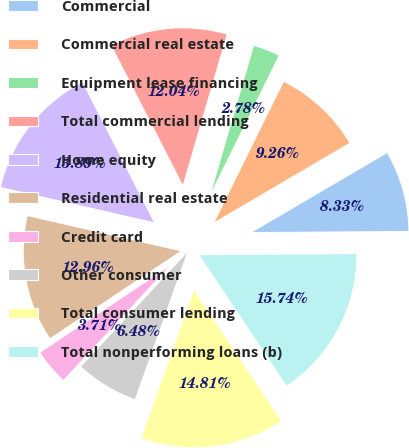Convert chart to OTSL. <chart><loc_0><loc_0><loc_500><loc_500><pie_chart><fcel>Commercial<fcel>Commercial real estate<fcel>Equipment lease financing<fcel>Total commercial lending<fcel>Home equity<fcel>Residential real estate<fcel>Credit card<fcel>Other consumer<fcel>Total consumer lending<fcel>Total nonperforming loans (b)<nl><fcel>8.33%<fcel>9.26%<fcel>2.78%<fcel>12.04%<fcel>13.89%<fcel>12.96%<fcel>3.71%<fcel>6.48%<fcel>14.81%<fcel>15.74%<nl></chart> 